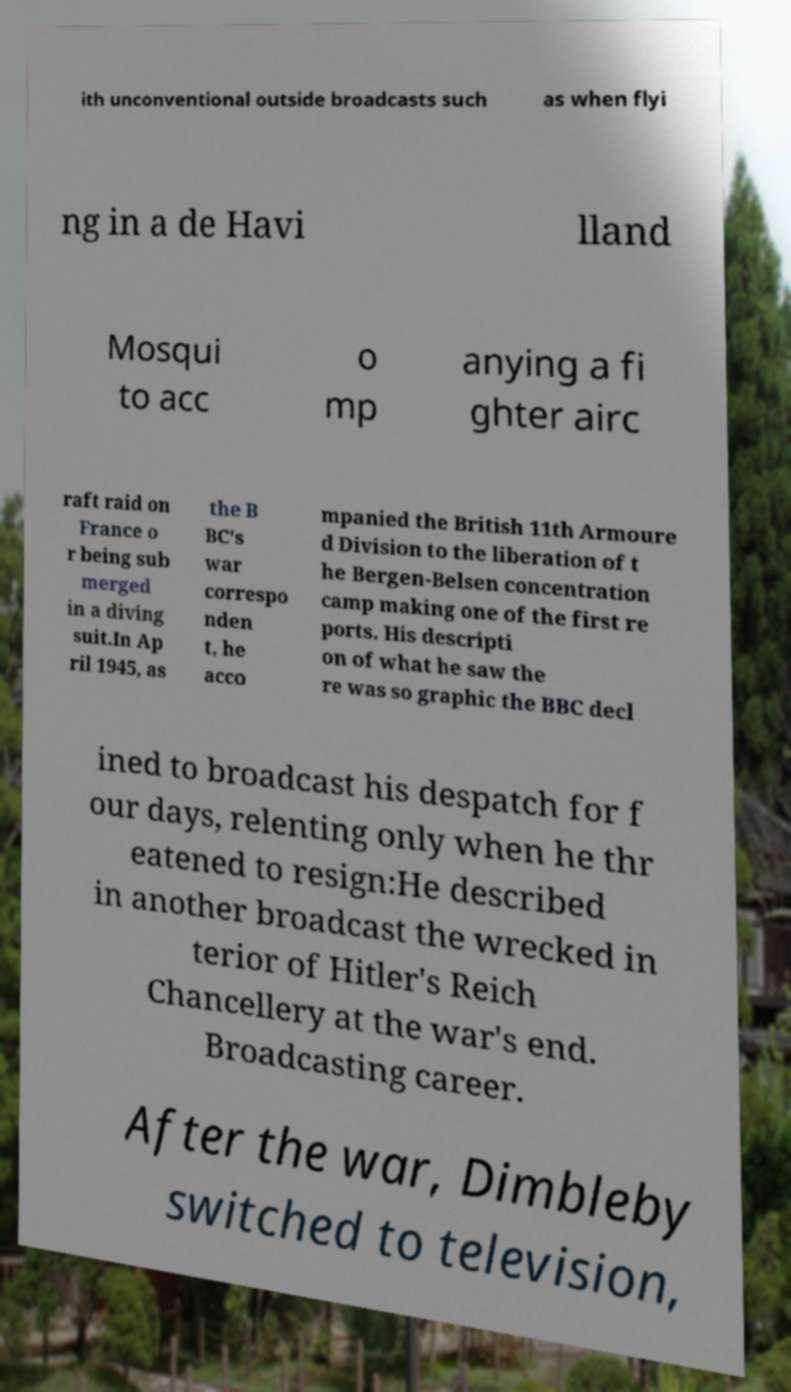Could you assist in decoding the text presented in this image and type it out clearly? ith unconventional outside broadcasts such as when flyi ng in a de Havi lland Mosqui to acc o mp anying a fi ghter airc raft raid on France o r being sub merged in a diving suit.In Ap ril 1945, as the B BC's war correspo nden t, he acco mpanied the British 11th Armoure d Division to the liberation of t he Bergen-Belsen concentration camp making one of the first re ports. His descripti on of what he saw the re was so graphic the BBC decl ined to broadcast his despatch for f our days, relenting only when he thr eatened to resign:He described in another broadcast the wrecked in terior of Hitler's Reich Chancellery at the war's end. Broadcasting career. After the war, Dimbleby switched to television, 